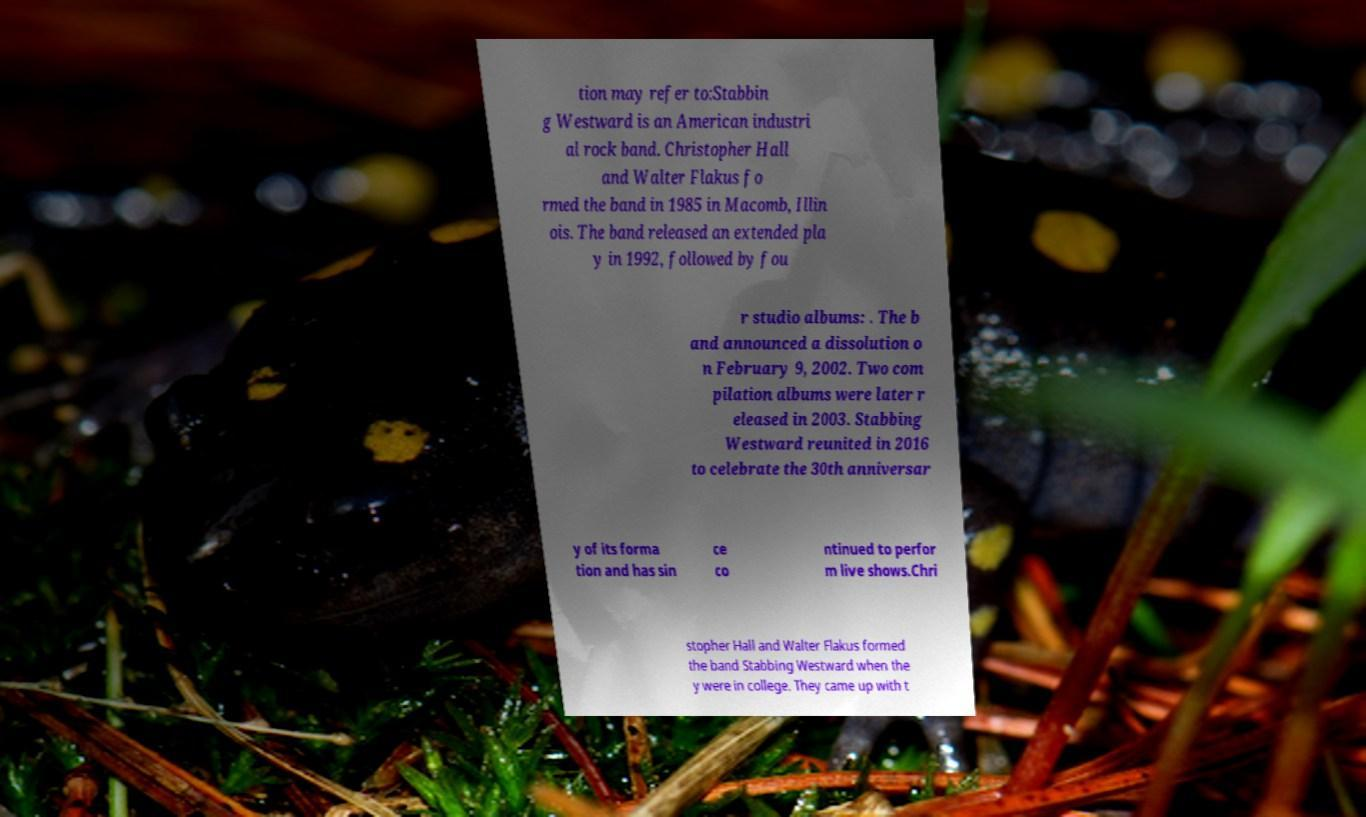For documentation purposes, I need the text within this image transcribed. Could you provide that? tion may refer to:Stabbin g Westward is an American industri al rock band. Christopher Hall and Walter Flakus fo rmed the band in 1985 in Macomb, Illin ois. The band released an extended pla y in 1992, followed by fou r studio albums: . The b and announced a dissolution o n February 9, 2002. Two com pilation albums were later r eleased in 2003. Stabbing Westward reunited in 2016 to celebrate the 30th anniversar y of its forma tion and has sin ce co ntinued to perfor m live shows.Chri stopher Hall and Walter Flakus formed the band Stabbing Westward when the y were in college. They came up with t 